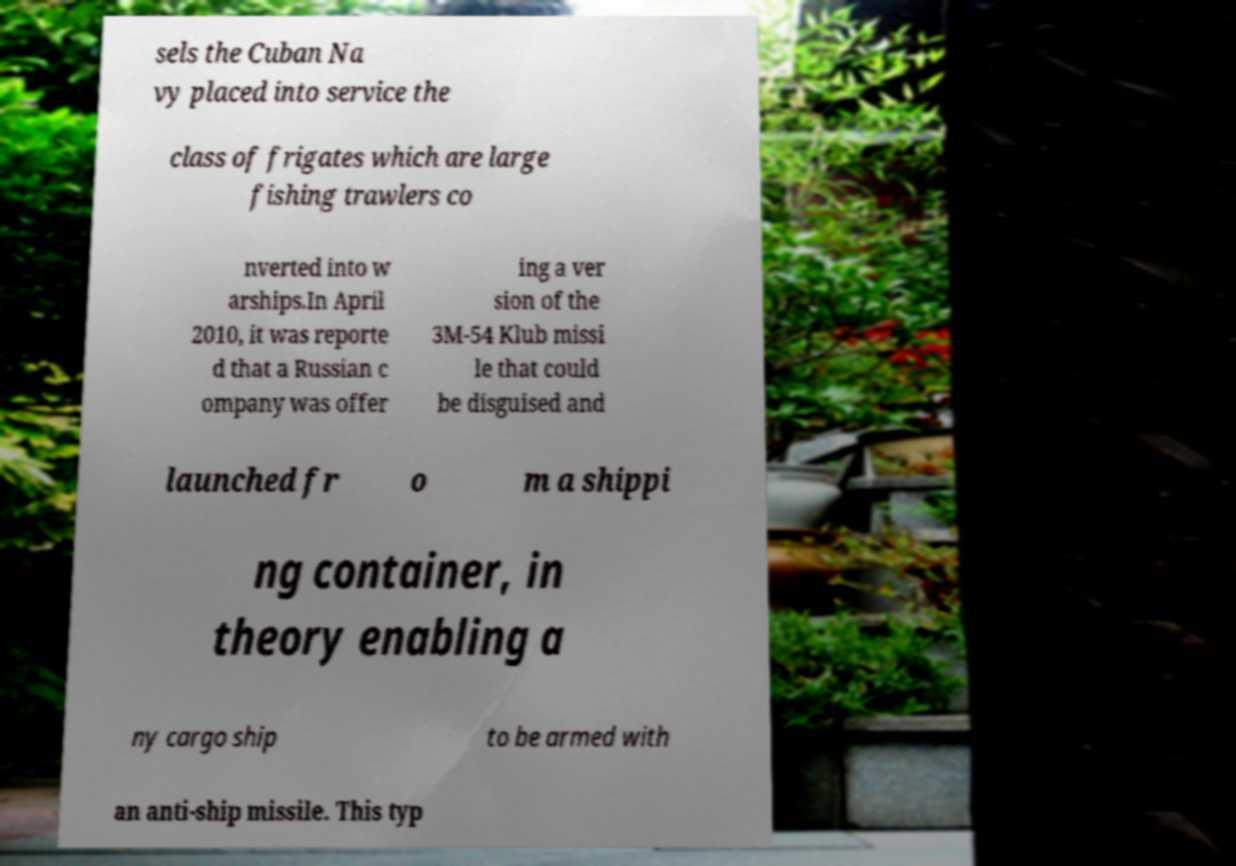I need the written content from this picture converted into text. Can you do that? sels the Cuban Na vy placed into service the class of frigates which are large fishing trawlers co nverted into w arships.In April 2010, it was reporte d that a Russian c ompany was offer ing a ver sion of the 3M-54 Klub missi le that could be disguised and launched fr o m a shippi ng container, in theory enabling a ny cargo ship to be armed with an anti-ship missile. This typ 